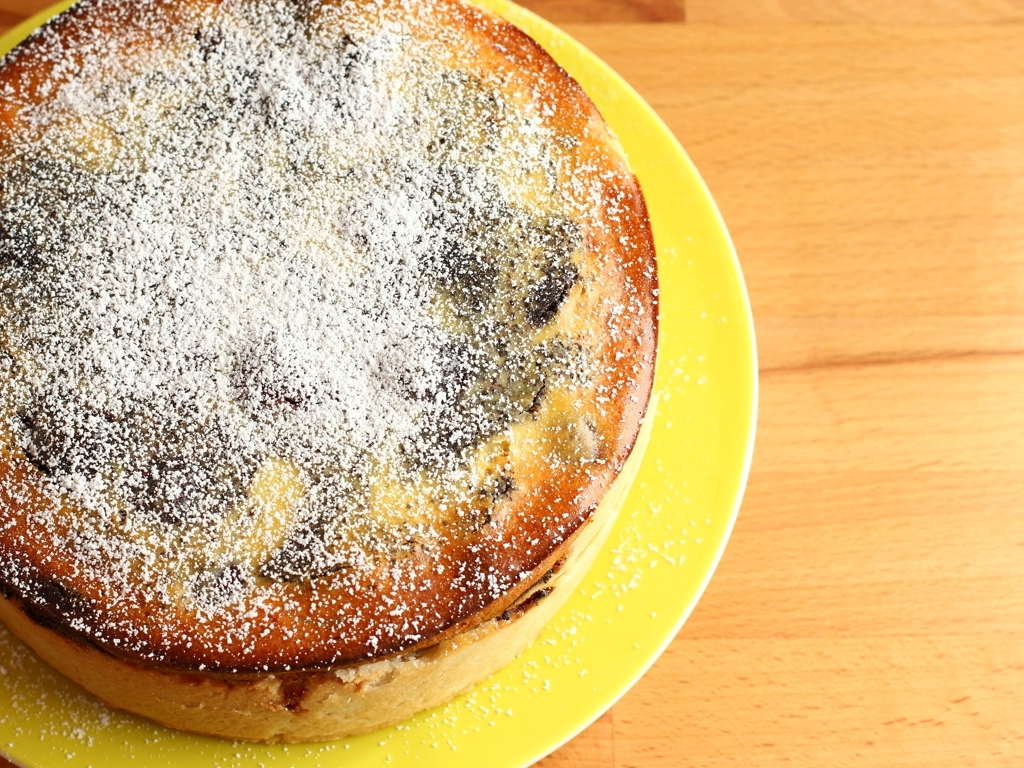Could this cake be suitable for a special occasion, and how might it be served? Yes, this cake's simple elegance would make it suitable for a variety of special occasions, from birthdays to tea parties. It would be best served with a dollop of whipped cream or fresh berries to complement its light sweetness, and perhaps a drizzle of honey or fruit coulis for added flair. 